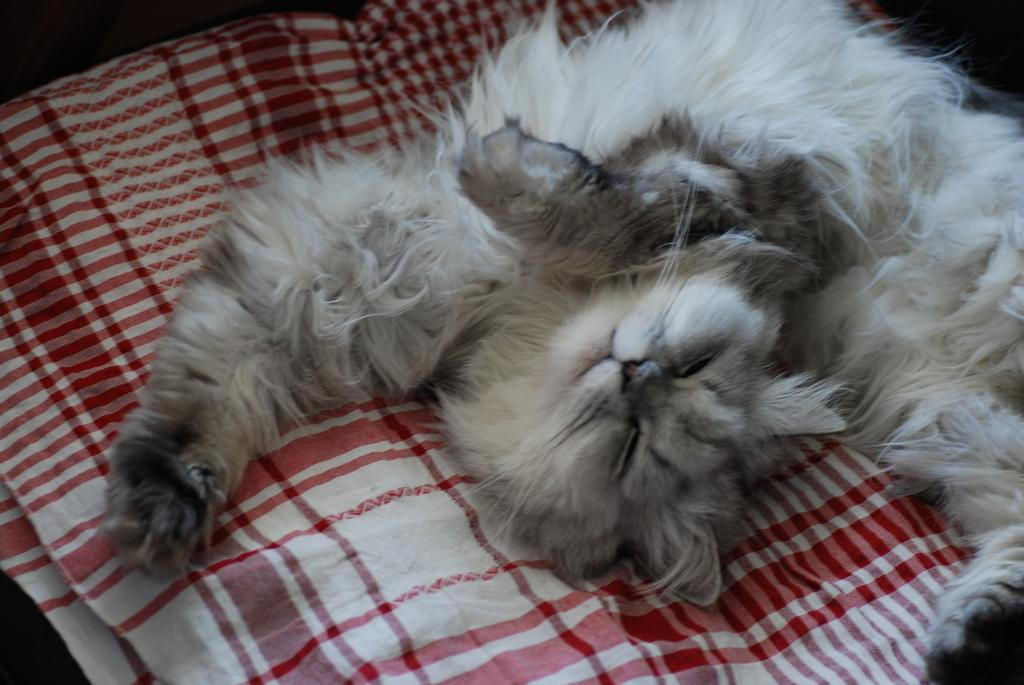What type of animal is in the image? There is a cat in the image. What is the cat doing in the image? The cat is sleeping in the image. Where is the cat located in relation to the image? The cat is in the foreground of the image. What is the cat resting on in the image? The cat is on a blanket in the image. What type of home does the maid live in, as seen in the image? There is no mention of a home or a maid in the image; it features a sleeping cat on a blanket. 